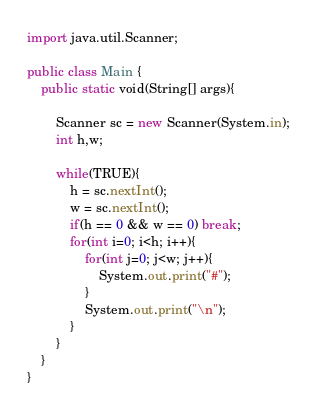<code> <loc_0><loc_0><loc_500><loc_500><_Java_>import java.util.Scanner;

public class Main {
	public static void(String[] args){

		Scanner sc = new Scanner(System.in);
		int h,w;
		
		while(TRUE){
			h = sc.nextInt();
			w = sc.nextInt();
			if(h == 0 && w == 0) break;
			for(int i=0; i<h; i++){
				for(int j=0; j<w; j++){
					System.out.print("#");
				}
				System.out.print("\n");
			}
		}
	}
}</code> 